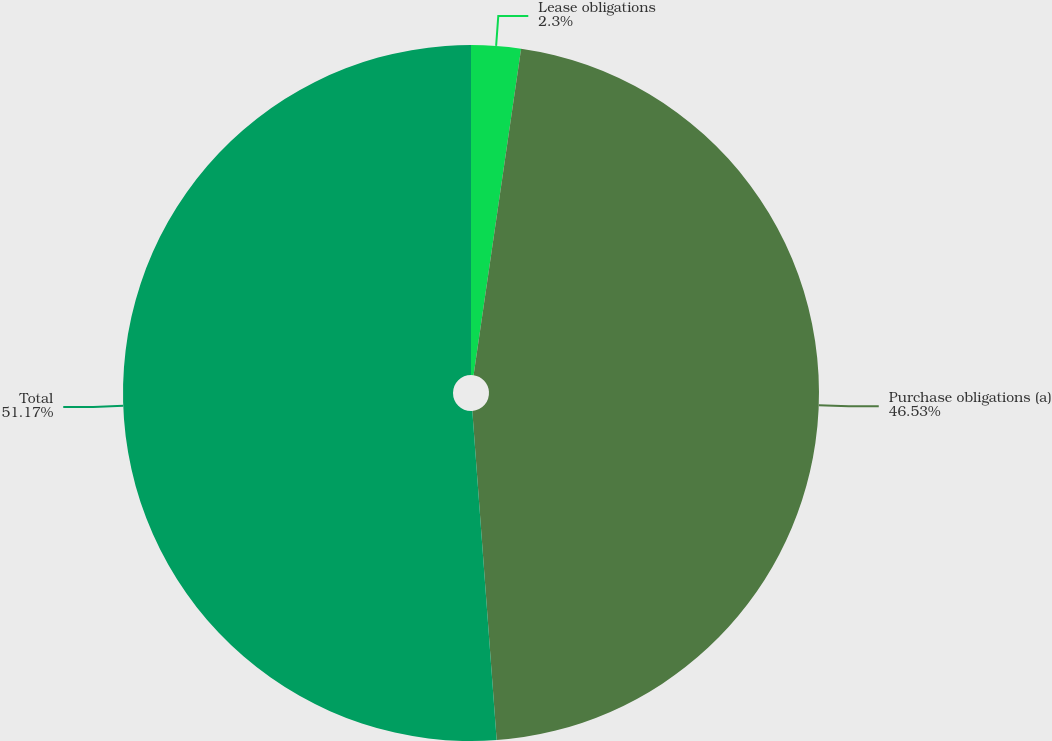Convert chart. <chart><loc_0><loc_0><loc_500><loc_500><pie_chart><fcel>Lease obligations<fcel>Purchase obligations (a)<fcel>Total<nl><fcel>2.3%<fcel>46.53%<fcel>51.18%<nl></chart> 